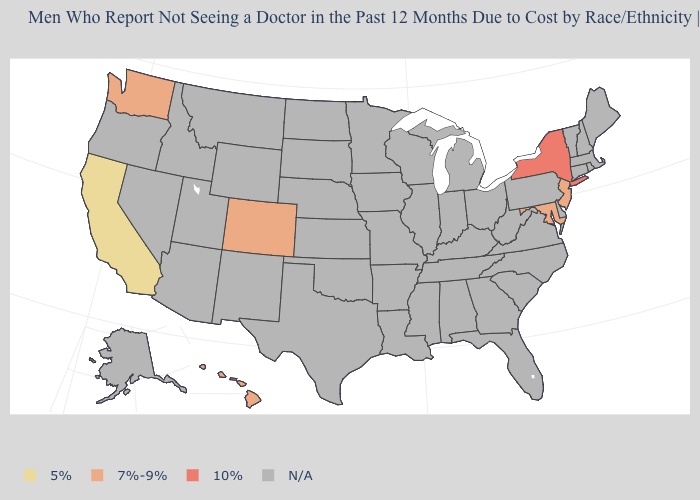Does California have the lowest value in the USA?
Keep it brief. Yes. What is the value of Pennsylvania?
Concise answer only. N/A. What is the value of Idaho?
Concise answer only. N/A. What is the value of Vermont?
Keep it brief. N/A. Does Washington have the lowest value in the USA?
Write a very short answer. No. Name the states that have a value in the range 5%?
Be succinct. California. What is the lowest value in states that border New York?
Answer briefly. 7%-9%. Name the states that have a value in the range N/A?
Concise answer only. Alabama, Alaska, Arizona, Arkansas, Connecticut, Delaware, Florida, Georgia, Idaho, Illinois, Indiana, Iowa, Kansas, Kentucky, Louisiana, Maine, Massachusetts, Michigan, Minnesota, Mississippi, Missouri, Montana, Nebraska, Nevada, New Hampshire, New Mexico, North Carolina, North Dakota, Ohio, Oklahoma, Oregon, Pennsylvania, Rhode Island, South Carolina, South Dakota, Tennessee, Texas, Utah, Vermont, Virginia, West Virginia, Wisconsin, Wyoming. Name the states that have a value in the range N/A?
Keep it brief. Alabama, Alaska, Arizona, Arkansas, Connecticut, Delaware, Florida, Georgia, Idaho, Illinois, Indiana, Iowa, Kansas, Kentucky, Louisiana, Maine, Massachusetts, Michigan, Minnesota, Mississippi, Missouri, Montana, Nebraska, Nevada, New Hampshire, New Mexico, North Carolina, North Dakota, Ohio, Oklahoma, Oregon, Pennsylvania, Rhode Island, South Carolina, South Dakota, Tennessee, Texas, Utah, Vermont, Virginia, West Virginia, Wisconsin, Wyoming. Which states have the lowest value in the USA?
Quick response, please. California. Name the states that have a value in the range 7%-9%?
Answer briefly. Colorado, Hawaii, Maryland, New Jersey, Washington. What is the value of New Jersey?
Short answer required. 7%-9%. Name the states that have a value in the range 5%?
Keep it brief. California. 